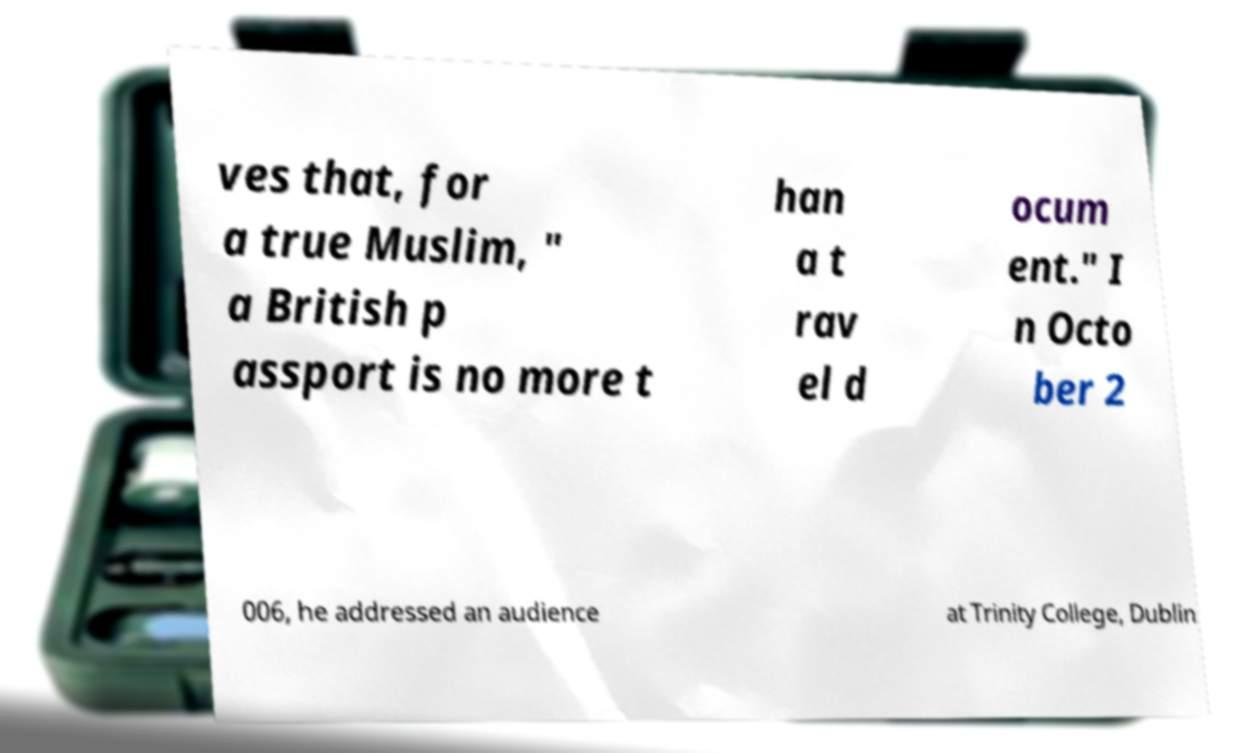Could you assist in decoding the text presented in this image and type it out clearly? ves that, for a true Muslim, " a British p assport is no more t han a t rav el d ocum ent." I n Octo ber 2 006, he addressed an audience at Trinity College, Dublin 